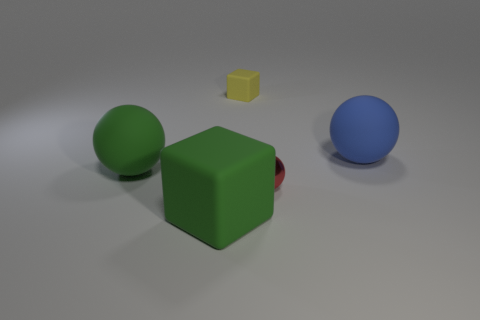Subtract all yellow blocks. Subtract all purple balls. How many blocks are left? 1 Add 1 small yellow objects. How many objects exist? 6 Subtract all balls. How many objects are left? 2 Add 3 red metal things. How many red metal things are left? 4 Add 5 tiny brown cubes. How many tiny brown cubes exist? 5 Subtract 0 cyan balls. How many objects are left? 5 Subtract all red cylinders. Subtract all yellow matte objects. How many objects are left? 4 